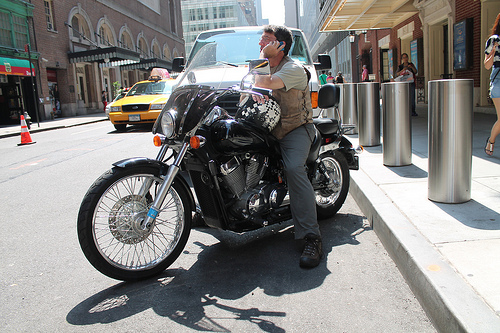Is the motorbike to the left or to the right of the orange cone? The motorbike is parked on the right side of the orange traffic cone. 